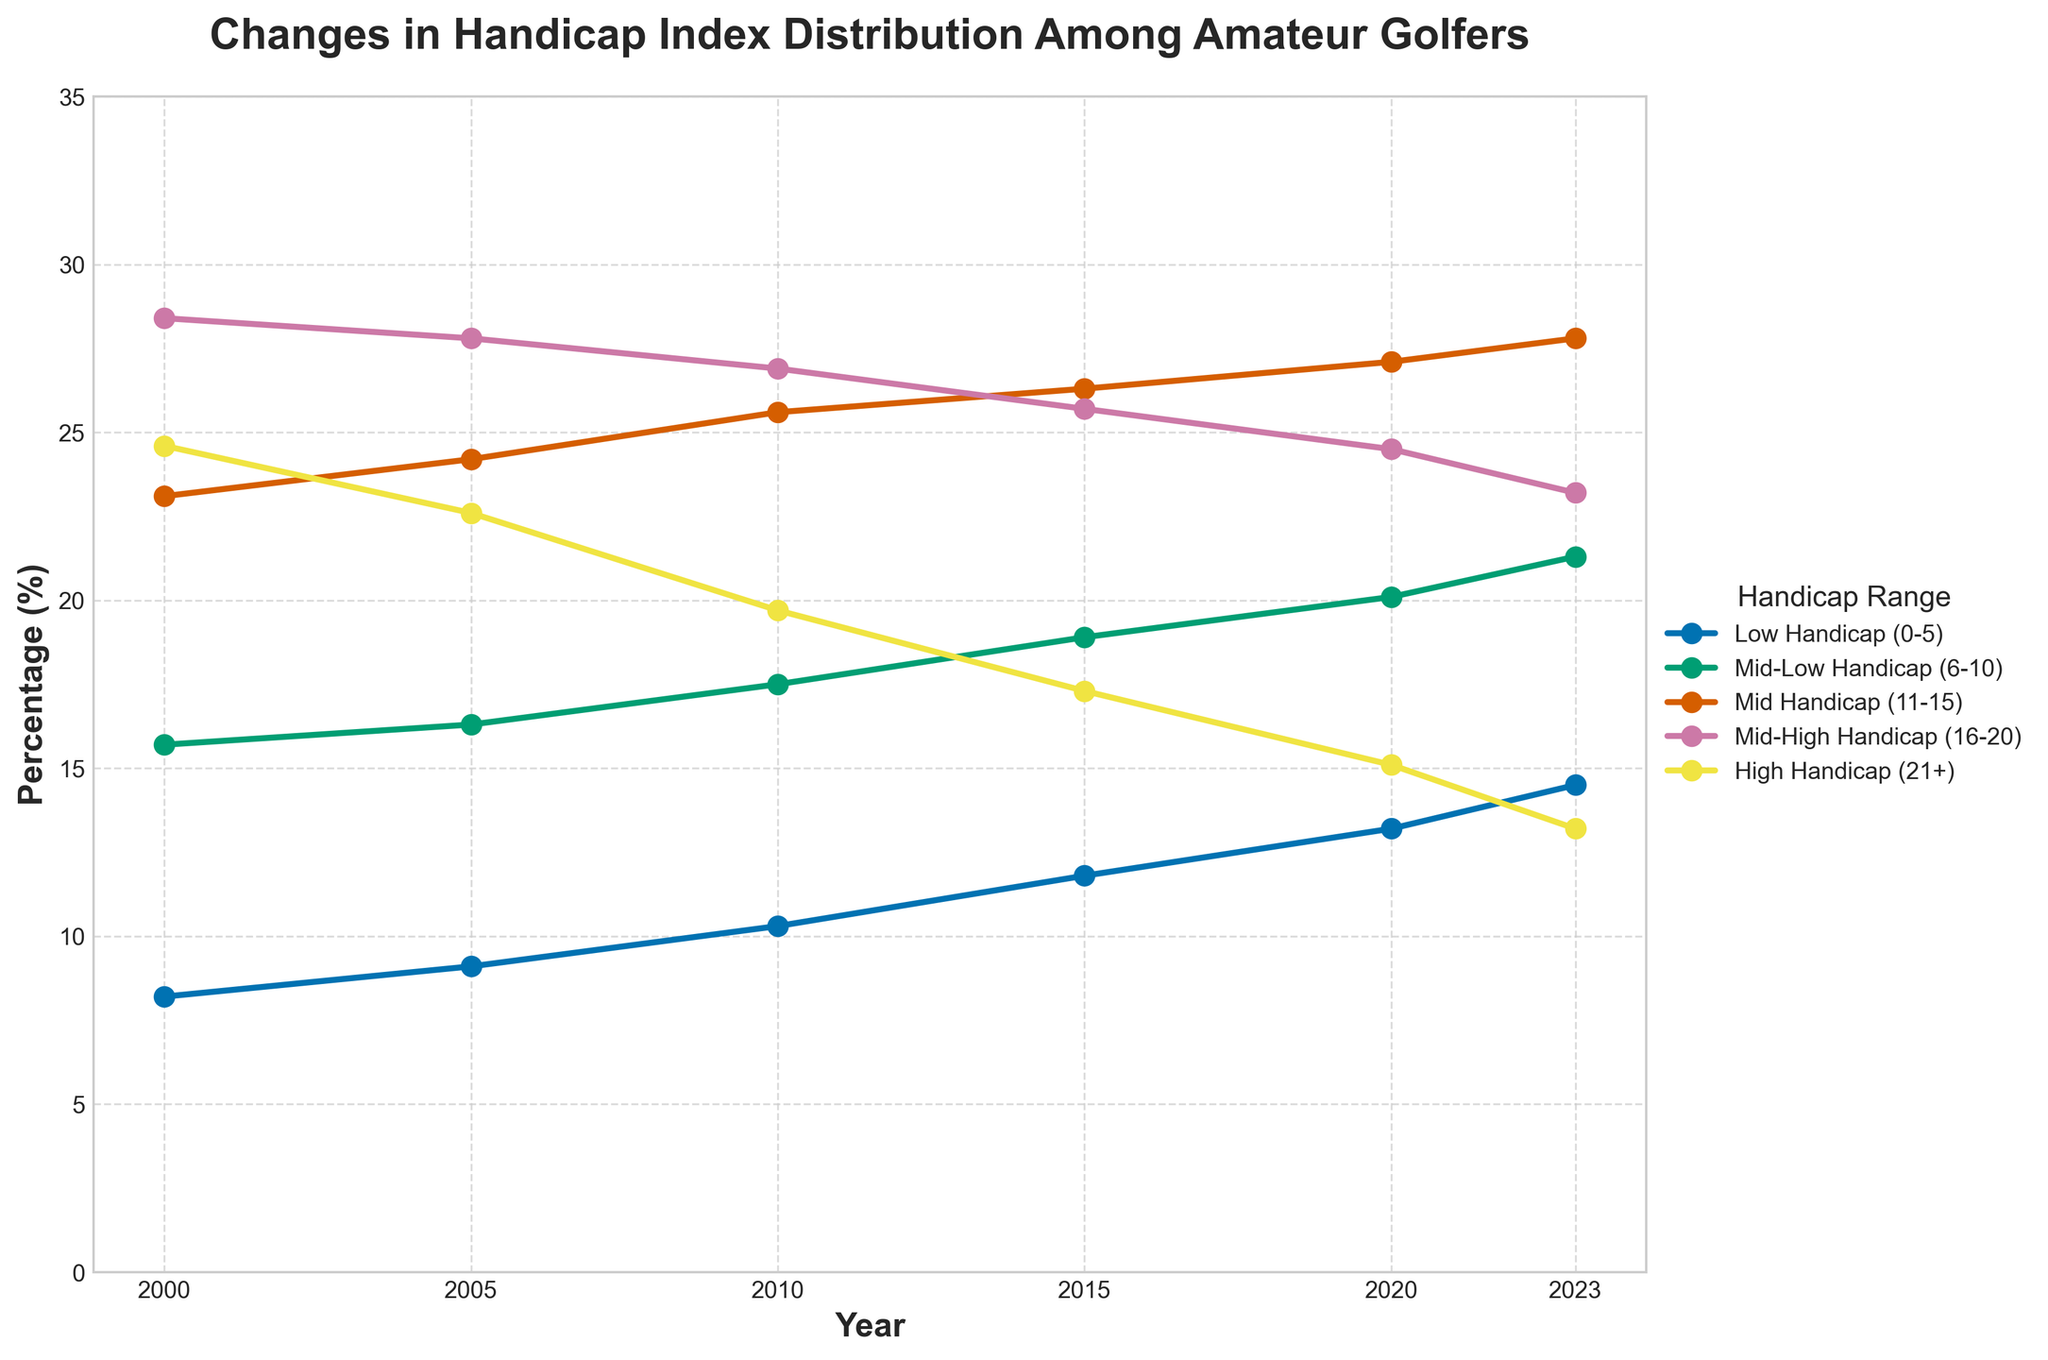What was the percentage change in the number of Low Handicap (0-5) golfers from 2000 to 2023? To find the percentage change, we subtract the 2000 value from the 2023 value, divide by the 2000 value, and then multiply by 100. The calculation is ((14.5 - 8.2) / 8.2) * 100.
Answer: 76.8% How did the proportion of High Handicap (21+) golfers change from 2000 to 2023? The percentage of High Handicap (21+) golfers in 2000 was 24.6%, and in 2023 it was 13.2%. The change can be found by subtracting the 2023 value from the 2000 value. 24.6 - 13.2 = 11.4.
Answer: Decreased by 11.4% Which handicap range showed the highest increase over the given period? By visually comparing the starting and ending points for each handicap range, we observe that the Low Handicap (0-5) range went from 8.2% in 2000 to 14.5% in 2023, which is an increase of 6.3. The comparison confirms that this is the highest increase among all ranges.
Answer: Low Handicap (0-5) In which year did the Mid-High Handicap (16-20) percentage drop below 25% for the first time? Observing the line for Mid-High Handicap (16-20), we see that the percentage drops below 25% in 2015, where it is precisely 25.7% in 2015 and 24.5% in 2020.
Answer: 2020 What was the combined percentage of golfers in the Low and Mid-Low Handicap ranges (0-10) in 2010? To find this, we sum the percentages of the Low Handicap (0-5) and Mid-Low Handicap (6-10) ranges in 2010: 10.3 + 17.5 = 27.8.
Answer: 27.8% How does the percentage of Mid Handicap (11-15) golfers in 2023 compare to that in 2000? By observing the Mid Handicap (11-15) values, we see that it was 23.1% in 2000 and 27.8% in 2023. Comparing these values shows an increase of 4.7%.
Answer: Increased by 4.7% What is the trend in the Mid-Low Handicap (6-10) group from 2000 to 2023? Examining the line for the Mid-Low Handicap (6-10) group, we see consistent increases each year: 15.7% in 2000, 16.3% in 2005, 17.5% in 2010, 18.9% in 2015, 20.1% in 2020, and 21.3% in 2023.
Answer: Consistently increasing Which two handicap ranges had the closest values in 2023? Looking at the values for each range in 2023, the Mid-High Handicap (16-20) and High Handicap (21+) ranges had the closest values, being 23.2% and 13.2% respectively.
Answer: Mid-High Handicap (16-20) and High Handicap (21+) Compare the percentage of Low Handicap (0-5) golfers in 2005 and 2015. Which year had more, and by how much? The percentage in 2005 was 9.1%, and in 2015 it was 11.8%. Subtracting 9.1 from 11.8 gives an increase of 2.7%.
Answer: 2015 had more by 2.7% 